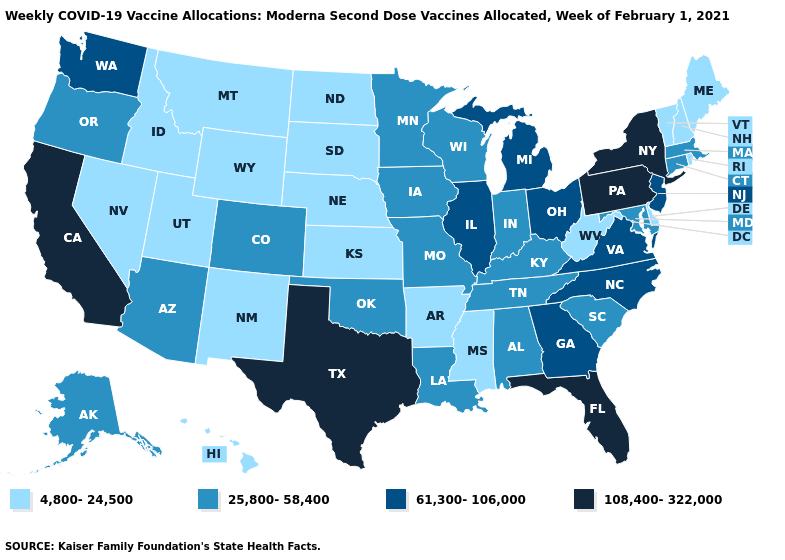What is the lowest value in the USA?
Write a very short answer. 4,800-24,500. Among the states that border Oregon , does California have the highest value?
Keep it brief. Yes. Which states have the lowest value in the USA?
Quick response, please. Arkansas, Delaware, Hawaii, Idaho, Kansas, Maine, Mississippi, Montana, Nebraska, Nevada, New Hampshire, New Mexico, North Dakota, Rhode Island, South Dakota, Utah, Vermont, West Virginia, Wyoming. Among the states that border North Dakota , which have the highest value?
Short answer required. Minnesota. Does the first symbol in the legend represent the smallest category?
Answer briefly. Yes. Does Missouri have a higher value than Massachusetts?
Be succinct. No. Among the states that border Oregon , does Nevada have the lowest value?
Quick response, please. Yes. Does the first symbol in the legend represent the smallest category?
Be succinct. Yes. Among the states that border North Carolina , which have the highest value?
Be succinct. Georgia, Virginia. Name the states that have a value in the range 108,400-322,000?
Be succinct. California, Florida, New York, Pennsylvania, Texas. What is the value of Oklahoma?
Write a very short answer. 25,800-58,400. Which states have the lowest value in the USA?
Give a very brief answer. Arkansas, Delaware, Hawaii, Idaho, Kansas, Maine, Mississippi, Montana, Nebraska, Nevada, New Hampshire, New Mexico, North Dakota, Rhode Island, South Dakota, Utah, Vermont, West Virginia, Wyoming. Name the states that have a value in the range 25,800-58,400?
Give a very brief answer. Alabama, Alaska, Arizona, Colorado, Connecticut, Indiana, Iowa, Kentucky, Louisiana, Maryland, Massachusetts, Minnesota, Missouri, Oklahoma, Oregon, South Carolina, Tennessee, Wisconsin. Among the states that border Missouri , does Tennessee have the lowest value?
Write a very short answer. No. 